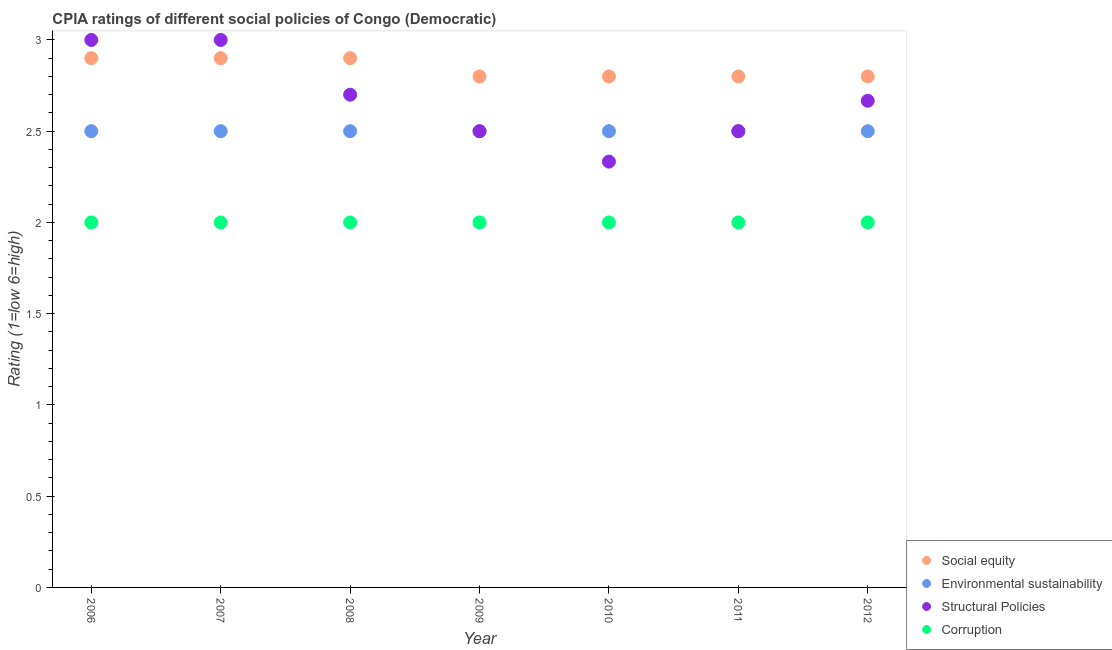Across all years, what is the minimum cpia rating of structural policies?
Your response must be concise. 2.33. What is the total cpia rating of corruption in the graph?
Offer a very short reply. 14. What is the difference between the cpia rating of structural policies in 2010 and that in 2011?
Your response must be concise. -0.17. What is the difference between the cpia rating of structural policies in 2011 and the cpia rating of corruption in 2007?
Keep it short and to the point. 0.5. What is the average cpia rating of structural policies per year?
Offer a very short reply. 2.67. In the year 2006, what is the difference between the cpia rating of structural policies and cpia rating of social equity?
Offer a terse response. 0.1. Is the difference between the cpia rating of corruption in 2006 and 2010 greater than the difference between the cpia rating of environmental sustainability in 2006 and 2010?
Offer a terse response. No. What is the difference between the highest and the second highest cpia rating of environmental sustainability?
Your answer should be compact. 0. What is the difference between the highest and the lowest cpia rating of structural policies?
Your answer should be very brief. 0.67. Is the sum of the cpia rating of social equity in 2008 and 2009 greater than the maximum cpia rating of structural policies across all years?
Your response must be concise. Yes. Does the cpia rating of structural policies monotonically increase over the years?
Ensure brevity in your answer.  No. How many dotlines are there?
Your answer should be very brief. 4. How many years are there in the graph?
Your response must be concise. 7. Are the values on the major ticks of Y-axis written in scientific E-notation?
Provide a succinct answer. No. Does the graph contain any zero values?
Offer a very short reply. No. Does the graph contain grids?
Provide a short and direct response. No. Where does the legend appear in the graph?
Your answer should be compact. Bottom right. How many legend labels are there?
Provide a short and direct response. 4. What is the title of the graph?
Offer a very short reply. CPIA ratings of different social policies of Congo (Democratic). Does "Taxes on goods and services" appear as one of the legend labels in the graph?
Your response must be concise. No. What is the Rating (1=low 6=high) in Environmental sustainability in 2006?
Offer a very short reply. 2.5. What is the Rating (1=low 6=high) in Structural Policies in 2006?
Keep it short and to the point. 3. What is the Rating (1=low 6=high) of Social equity in 2007?
Give a very brief answer. 2.9. What is the Rating (1=low 6=high) in Environmental sustainability in 2007?
Offer a very short reply. 2.5. What is the Rating (1=low 6=high) of Environmental sustainability in 2008?
Provide a succinct answer. 2.5. What is the Rating (1=low 6=high) of Structural Policies in 2008?
Your answer should be very brief. 2.7. What is the Rating (1=low 6=high) in Corruption in 2008?
Your answer should be compact. 2. What is the Rating (1=low 6=high) of Social equity in 2009?
Provide a succinct answer. 2.8. What is the Rating (1=low 6=high) in Environmental sustainability in 2009?
Offer a very short reply. 2.5. What is the Rating (1=low 6=high) in Social equity in 2010?
Provide a short and direct response. 2.8. What is the Rating (1=low 6=high) in Structural Policies in 2010?
Offer a terse response. 2.33. What is the Rating (1=low 6=high) in Corruption in 2010?
Keep it short and to the point. 2. What is the Rating (1=low 6=high) of Social equity in 2011?
Provide a succinct answer. 2.8. What is the Rating (1=low 6=high) of Social equity in 2012?
Your answer should be very brief. 2.8. What is the Rating (1=low 6=high) of Environmental sustainability in 2012?
Provide a short and direct response. 2.5. What is the Rating (1=low 6=high) in Structural Policies in 2012?
Make the answer very short. 2.67. What is the Rating (1=low 6=high) of Corruption in 2012?
Your answer should be compact. 2. Across all years, what is the maximum Rating (1=low 6=high) in Structural Policies?
Provide a short and direct response. 3. Across all years, what is the minimum Rating (1=low 6=high) in Social equity?
Offer a very short reply. 2.8. Across all years, what is the minimum Rating (1=low 6=high) in Structural Policies?
Keep it short and to the point. 2.33. What is the total Rating (1=low 6=high) in Environmental sustainability in the graph?
Keep it short and to the point. 17.5. What is the total Rating (1=low 6=high) of Structural Policies in the graph?
Offer a terse response. 18.7. What is the difference between the Rating (1=low 6=high) in Social equity in 2006 and that in 2007?
Make the answer very short. 0. What is the difference between the Rating (1=low 6=high) of Corruption in 2006 and that in 2007?
Keep it short and to the point. 0. What is the difference between the Rating (1=low 6=high) in Structural Policies in 2006 and that in 2008?
Ensure brevity in your answer.  0.3. What is the difference between the Rating (1=low 6=high) in Structural Policies in 2006 and that in 2009?
Your answer should be compact. 0.5. What is the difference between the Rating (1=low 6=high) of Structural Policies in 2006 and that in 2010?
Give a very brief answer. 0.67. What is the difference between the Rating (1=low 6=high) in Corruption in 2006 and that in 2010?
Offer a very short reply. 0. What is the difference between the Rating (1=low 6=high) of Structural Policies in 2006 and that in 2011?
Keep it short and to the point. 0.5. What is the difference between the Rating (1=low 6=high) in Structural Policies in 2006 and that in 2012?
Provide a succinct answer. 0.33. What is the difference between the Rating (1=low 6=high) in Social equity in 2007 and that in 2008?
Give a very brief answer. 0. What is the difference between the Rating (1=low 6=high) of Structural Policies in 2007 and that in 2008?
Give a very brief answer. 0.3. What is the difference between the Rating (1=low 6=high) of Environmental sustainability in 2007 and that in 2009?
Offer a very short reply. 0. What is the difference between the Rating (1=low 6=high) of Environmental sustainability in 2007 and that in 2010?
Provide a succinct answer. 0. What is the difference between the Rating (1=low 6=high) in Structural Policies in 2007 and that in 2010?
Provide a short and direct response. 0.67. What is the difference between the Rating (1=low 6=high) in Corruption in 2007 and that in 2010?
Your answer should be compact. 0. What is the difference between the Rating (1=low 6=high) of Environmental sustainability in 2007 and that in 2012?
Provide a short and direct response. 0. What is the difference between the Rating (1=low 6=high) of Environmental sustainability in 2008 and that in 2009?
Provide a succinct answer. 0. What is the difference between the Rating (1=low 6=high) of Structural Policies in 2008 and that in 2010?
Make the answer very short. 0.37. What is the difference between the Rating (1=low 6=high) in Environmental sustainability in 2008 and that in 2011?
Your response must be concise. 0. What is the difference between the Rating (1=low 6=high) in Corruption in 2008 and that in 2012?
Make the answer very short. 0. What is the difference between the Rating (1=low 6=high) of Social equity in 2009 and that in 2010?
Ensure brevity in your answer.  0. What is the difference between the Rating (1=low 6=high) of Environmental sustainability in 2009 and that in 2010?
Make the answer very short. 0. What is the difference between the Rating (1=low 6=high) of Structural Policies in 2009 and that in 2010?
Provide a succinct answer. 0.17. What is the difference between the Rating (1=low 6=high) of Corruption in 2009 and that in 2010?
Ensure brevity in your answer.  0. What is the difference between the Rating (1=low 6=high) in Corruption in 2009 and that in 2012?
Offer a terse response. 0. What is the difference between the Rating (1=low 6=high) of Social equity in 2010 and that in 2011?
Keep it short and to the point. 0. What is the difference between the Rating (1=low 6=high) of Structural Policies in 2010 and that in 2011?
Your response must be concise. -0.17. What is the difference between the Rating (1=low 6=high) of Corruption in 2010 and that in 2011?
Keep it short and to the point. 0. What is the difference between the Rating (1=low 6=high) of Social equity in 2010 and that in 2012?
Your answer should be very brief. 0. What is the difference between the Rating (1=low 6=high) in Structural Policies in 2010 and that in 2012?
Provide a short and direct response. -0.33. What is the difference between the Rating (1=low 6=high) in Social equity in 2011 and that in 2012?
Ensure brevity in your answer.  0. What is the difference between the Rating (1=low 6=high) of Structural Policies in 2011 and that in 2012?
Give a very brief answer. -0.17. What is the difference between the Rating (1=low 6=high) in Corruption in 2011 and that in 2012?
Make the answer very short. 0. What is the difference between the Rating (1=low 6=high) in Social equity in 2006 and the Rating (1=low 6=high) in Environmental sustainability in 2007?
Provide a short and direct response. 0.4. What is the difference between the Rating (1=low 6=high) in Social equity in 2006 and the Rating (1=low 6=high) in Corruption in 2007?
Your answer should be very brief. 0.9. What is the difference between the Rating (1=low 6=high) in Environmental sustainability in 2006 and the Rating (1=low 6=high) in Structural Policies in 2007?
Provide a short and direct response. -0.5. What is the difference between the Rating (1=low 6=high) of Environmental sustainability in 2006 and the Rating (1=low 6=high) of Corruption in 2007?
Provide a short and direct response. 0.5. What is the difference between the Rating (1=low 6=high) of Structural Policies in 2006 and the Rating (1=low 6=high) of Corruption in 2008?
Ensure brevity in your answer.  1. What is the difference between the Rating (1=low 6=high) of Social equity in 2006 and the Rating (1=low 6=high) of Structural Policies in 2009?
Keep it short and to the point. 0.4. What is the difference between the Rating (1=low 6=high) in Environmental sustainability in 2006 and the Rating (1=low 6=high) in Corruption in 2009?
Your response must be concise. 0.5. What is the difference between the Rating (1=low 6=high) in Structural Policies in 2006 and the Rating (1=low 6=high) in Corruption in 2009?
Your answer should be compact. 1. What is the difference between the Rating (1=low 6=high) of Social equity in 2006 and the Rating (1=low 6=high) of Environmental sustainability in 2010?
Keep it short and to the point. 0.4. What is the difference between the Rating (1=low 6=high) of Social equity in 2006 and the Rating (1=low 6=high) of Structural Policies in 2010?
Provide a succinct answer. 0.57. What is the difference between the Rating (1=low 6=high) of Social equity in 2006 and the Rating (1=low 6=high) of Corruption in 2010?
Ensure brevity in your answer.  0.9. What is the difference between the Rating (1=low 6=high) of Environmental sustainability in 2006 and the Rating (1=low 6=high) of Structural Policies in 2010?
Provide a short and direct response. 0.17. What is the difference between the Rating (1=low 6=high) of Environmental sustainability in 2006 and the Rating (1=low 6=high) of Corruption in 2010?
Offer a terse response. 0.5. What is the difference between the Rating (1=low 6=high) of Social equity in 2006 and the Rating (1=low 6=high) of Environmental sustainability in 2011?
Offer a terse response. 0.4. What is the difference between the Rating (1=low 6=high) of Social equity in 2006 and the Rating (1=low 6=high) of Structural Policies in 2011?
Give a very brief answer. 0.4. What is the difference between the Rating (1=low 6=high) of Social equity in 2006 and the Rating (1=low 6=high) of Corruption in 2011?
Your response must be concise. 0.9. What is the difference between the Rating (1=low 6=high) of Structural Policies in 2006 and the Rating (1=low 6=high) of Corruption in 2011?
Offer a terse response. 1. What is the difference between the Rating (1=low 6=high) in Social equity in 2006 and the Rating (1=low 6=high) in Structural Policies in 2012?
Provide a short and direct response. 0.23. What is the difference between the Rating (1=low 6=high) in Social equity in 2006 and the Rating (1=low 6=high) in Corruption in 2012?
Offer a terse response. 0.9. What is the difference between the Rating (1=low 6=high) in Social equity in 2007 and the Rating (1=low 6=high) in Structural Policies in 2008?
Provide a short and direct response. 0.2. What is the difference between the Rating (1=low 6=high) in Social equity in 2007 and the Rating (1=low 6=high) in Corruption in 2008?
Your answer should be very brief. 0.9. What is the difference between the Rating (1=low 6=high) of Social equity in 2007 and the Rating (1=low 6=high) of Environmental sustainability in 2009?
Provide a succinct answer. 0.4. What is the difference between the Rating (1=low 6=high) in Social equity in 2007 and the Rating (1=low 6=high) in Corruption in 2009?
Offer a terse response. 0.9. What is the difference between the Rating (1=low 6=high) of Structural Policies in 2007 and the Rating (1=low 6=high) of Corruption in 2009?
Give a very brief answer. 1. What is the difference between the Rating (1=low 6=high) in Social equity in 2007 and the Rating (1=low 6=high) in Environmental sustainability in 2010?
Your answer should be very brief. 0.4. What is the difference between the Rating (1=low 6=high) in Social equity in 2007 and the Rating (1=low 6=high) in Structural Policies in 2010?
Offer a very short reply. 0.57. What is the difference between the Rating (1=low 6=high) in Social equity in 2007 and the Rating (1=low 6=high) in Corruption in 2010?
Your answer should be compact. 0.9. What is the difference between the Rating (1=low 6=high) in Structural Policies in 2007 and the Rating (1=low 6=high) in Corruption in 2010?
Offer a terse response. 1. What is the difference between the Rating (1=low 6=high) in Social equity in 2007 and the Rating (1=low 6=high) in Corruption in 2011?
Offer a very short reply. 0.9. What is the difference between the Rating (1=low 6=high) of Environmental sustainability in 2007 and the Rating (1=low 6=high) of Structural Policies in 2011?
Offer a terse response. 0. What is the difference between the Rating (1=low 6=high) in Environmental sustainability in 2007 and the Rating (1=low 6=high) in Corruption in 2011?
Your answer should be compact. 0.5. What is the difference between the Rating (1=low 6=high) in Structural Policies in 2007 and the Rating (1=low 6=high) in Corruption in 2011?
Keep it short and to the point. 1. What is the difference between the Rating (1=low 6=high) of Social equity in 2007 and the Rating (1=low 6=high) of Structural Policies in 2012?
Keep it short and to the point. 0.23. What is the difference between the Rating (1=low 6=high) of Environmental sustainability in 2007 and the Rating (1=low 6=high) of Structural Policies in 2012?
Offer a terse response. -0.17. What is the difference between the Rating (1=low 6=high) of Social equity in 2008 and the Rating (1=low 6=high) of Structural Policies in 2009?
Offer a terse response. 0.4. What is the difference between the Rating (1=low 6=high) of Social equity in 2008 and the Rating (1=low 6=high) of Corruption in 2009?
Make the answer very short. 0.9. What is the difference between the Rating (1=low 6=high) of Environmental sustainability in 2008 and the Rating (1=low 6=high) of Structural Policies in 2009?
Keep it short and to the point. 0. What is the difference between the Rating (1=low 6=high) of Environmental sustainability in 2008 and the Rating (1=low 6=high) of Corruption in 2009?
Offer a terse response. 0.5. What is the difference between the Rating (1=low 6=high) in Social equity in 2008 and the Rating (1=low 6=high) in Structural Policies in 2010?
Your response must be concise. 0.57. What is the difference between the Rating (1=low 6=high) in Social equity in 2008 and the Rating (1=low 6=high) in Corruption in 2010?
Your response must be concise. 0.9. What is the difference between the Rating (1=low 6=high) in Environmental sustainability in 2008 and the Rating (1=low 6=high) in Structural Policies in 2010?
Offer a terse response. 0.17. What is the difference between the Rating (1=low 6=high) of Environmental sustainability in 2008 and the Rating (1=low 6=high) of Corruption in 2010?
Offer a terse response. 0.5. What is the difference between the Rating (1=low 6=high) of Social equity in 2008 and the Rating (1=low 6=high) of Environmental sustainability in 2011?
Offer a very short reply. 0.4. What is the difference between the Rating (1=low 6=high) in Environmental sustainability in 2008 and the Rating (1=low 6=high) in Structural Policies in 2011?
Make the answer very short. 0. What is the difference between the Rating (1=low 6=high) of Structural Policies in 2008 and the Rating (1=low 6=high) of Corruption in 2011?
Provide a short and direct response. 0.7. What is the difference between the Rating (1=low 6=high) in Social equity in 2008 and the Rating (1=low 6=high) in Environmental sustainability in 2012?
Offer a terse response. 0.4. What is the difference between the Rating (1=low 6=high) of Social equity in 2008 and the Rating (1=low 6=high) of Structural Policies in 2012?
Provide a succinct answer. 0.23. What is the difference between the Rating (1=low 6=high) in Structural Policies in 2008 and the Rating (1=low 6=high) in Corruption in 2012?
Offer a very short reply. 0.7. What is the difference between the Rating (1=low 6=high) of Social equity in 2009 and the Rating (1=low 6=high) of Environmental sustainability in 2010?
Make the answer very short. 0.3. What is the difference between the Rating (1=low 6=high) in Social equity in 2009 and the Rating (1=low 6=high) in Structural Policies in 2010?
Your answer should be very brief. 0.47. What is the difference between the Rating (1=low 6=high) of Social equity in 2009 and the Rating (1=low 6=high) of Environmental sustainability in 2011?
Offer a terse response. 0.3. What is the difference between the Rating (1=low 6=high) in Social equity in 2009 and the Rating (1=low 6=high) in Structural Policies in 2011?
Offer a terse response. 0.3. What is the difference between the Rating (1=low 6=high) in Environmental sustainability in 2009 and the Rating (1=low 6=high) in Structural Policies in 2011?
Offer a very short reply. 0. What is the difference between the Rating (1=low 6=high) of Environmental sustainability in 2009 and the Rating (1=low 6=high) of Corruption in 2011?
Give a very brief answer. 0.5. What is the difference between the Rating (1=low 6=high) of Structural Policies in 2009 and the Rating (1=low 6=high) of Corruption in 2011?
Provide a short and direct response. 0.5. What is the difference between the Rating (1=low 6=high) in Social equity in 2009 and the Rating (1=low 6=high) in Structural Policies in 2012?
Offer a very short reply. 0.13. What is the difference between the Rating (1=low 6=high) in Social equity in 2009 and the Rating (1=low 6=high) in Corruption in 2012?
Ensure brevity in your answer.  0.8. What is the difference between the Rating (1=low 6=high) in Environmental sustainability in 2009 and the Rating (1=low 6=high) in Structural Policies in 2012?
Ensure brevity in your answer.  -0.17. What is the difference between the Rating (1=low 6=high) of Environmental sustainability in 2009 and the Rating (1=low 6=high) of Corruption in 2012?
Give a very brief answer. 0.5. What is the difference between the Rating (1=low 6=high) of Social equity in 2010 and the Rating (1=low 6=high) of Environmental sustainability in 2011?
Your response must be concise. 0.3. What is the difference between the Rating (1=low 6=high) of Social equity in 2010 and the Rating (1=low 6=high) of Corruption in 2011?
Ensure brevity in your answer.  0.8. What is the difference between the Rating (1=low 6=high) in Environmental sustainability in 2010 and the Rating (1=low 6=high) in Structural Policies in 2011?
Make the answer very short. 0. What is the difference between the Rating (1=low 6=high) in Structural Policies in 2010 and the Rating (1=low 6=high) in Corruption in 2011?
Keep it short and to the point. 0.33. What is the difference between the Rating (1=low 6=high) of Social equity in 2010 and the Rating (1=low 6=high) of Environmental sustainability in 2012?
Your response must be concise. 0.3. What is the difference between the Rating (1=low 6=high) in Social equity in 2010 and the Rating (1=low 6=high) in Structural Policies in 2012?
Your answer should be very brief. 0.13. What is the difference between the Rating (1=low 6=high) of Social equity in 2010 and the Rating (1=low 6=high) of Corruption in 2012?
Keep it short and to the point. 0.8. What is the difference between the Rating (1=low 6=high) in Social equity in 2011 and the Rating (1=low 6=high) in Structural Policies in 2012?
Ensure brevity in your answer.  0.13. What is the difference between the Rating (1=low 6=high) in Structural Policies in 2011 and the Rating (1=low 6=high) in Corruption in 2012?
Provide a succinct answer. 0.5. What is the average Rating (1=low 6=high) in Social equity per year?
Give a very brief answer. 2.84. What is the average Rating (1=low 6=high) in Environmental sustainability per year?
Provide a short and direct response. 2.5. What is the average Rating (1=low 6=high) in Structural Policies per year?
Offer a very short reply. 2.67. In the year 2006, what is the difference between the Rating (1=low 6=high) in Social equity and Rating (1=low 6=high) in Environmental sustainability?
Your response must be concise. 0.4. In the year 2006, what is the difference between the Rating (1=low 6=high) of Social equity and Rating (1=low 6=high) of Corruption?
Ensure brevity in your answer.  0.9. In the year 2006, what is the difference between the Rating (1=low 6=high) of Environmental sustainability and Rating (1=low 6=high) of Structural Policies?
Provide a short and direct response. -0.5. In the year 2006, what is the difference between the Rating (1=low 6=high) of Environmental sustainability and Rating (1=low 6=high) of Corruption?
Make the answer very short. 0.5. In the year 2006, what is the difference between the Rating (1=low 6=high) of Structural Policies and Rating (1=low 6=high) of Corruption?
Make the answer very short. 1. In the year 2007, what is the difference between the Rating (1=low 6=high) in Social equity and Rating (1=low 6=high) in Structural Policies?
Ensure brevity in your answer.  -0.1. In the year 2007, what is the difference between the Rating (1=low 6=high) of Environmental sustainability and Rating (1=low 6=high) of Structural Policies?
Keep it short and to the point. -0.5. In the year 2007, what is the difference between the Rating (1=low 6=high) in Structural Policies and Rating (1=low 6=high) in Corruption?
Provide a succinct answer. 1. In the year 2008, what is the difference between the Rating (1=low 6=high) of Social equity and Rating (1=low 6=high) of Environmental sustainability?
Your answer should be very brief. 0.4. In the year 2008, what is the difference between the Rating (1=low 6=high) of Social equity and Rating (1=low 6=high) of Structural Policies?
Offer a very short reply. 0.2. In the year 2008, what is the difference between the Rating (1=low 6=high) in Social equity and Rating (1=low 6=high) in Corruption?
Give a very brief answer. 0.9. In the year 2008, what is the difference between the Rating (1=low 6=high) of Environmental sustainability and Rating (1=low 6=high) of Corruption?
Ensure brevity in your answer.  0.5. In the year 2008, what is the difference between the Rating (1=low 6=high) of Structural Policies and Rating (1=low 6=high) of Corruption?
Your answer should be very brief. 0.7. In the year 2009, what is the difference between the Rating (1=low 6=high) of Social equity and Rating (1=low 6=high) of Environmental sustainability?
Your answer should be very brief. 0.3. In the year 2009, what is the difference between the Rating (1=low 6=high) of Social equity and Rating (1=low 6=high) of Structural Policies?
Give a very brief answer. 0.3. In the year 2009, what is the difference between the Rating (1=low 6=high) in Social equity and Rating (1=low 6=high) in Corruption?
Your response must be concise. 0.8. In the year 2009, what is the difference between the Rating (1=low 6=high) of Environmental sustainability and Rating (1=low 6=high) of Structural Policies?
Offer a very short reply. 0. In the year 2010, what is the difference between the Rating (1=low 6=high) in Social equity and Rating (1=low 6=high) in Environmental sustainability?
Ensure brevity in your answer.  0.3. In the year 2010, what is the difference between the Rating (1=low 6=high) in Social equity and Rating (1=low 6=high) in Structural Policies?
Keep it short and to the point. 0.47. In the year 2010, what is the difference between the Rating (1=low 6=high) of Social equity and Rating (1=low 6=high) of Corruption?
Provide a short and direct response. 0.8. In the year 2010, what is the difference between the Rating (1=low 6=high) of Environmental sustainability and Rating (1=low 6=high) of Structural Policies?
Offer a terse response. 0.17. In the year 2010, what is the difference between the Rating (1=low 6=high) in Environmental sustainability and Rating (1=low 6=high) in Corruption?
Provide a succinct answer. 0.5. In the year 2011, what is the difference between the Rating (1=low 6=high) in Social equity and Rating (1=low 6=high) in Structural Policies?
Ensure brevity in your answer.  0.3. In the year 2011, what is the difference between the Rating (1=low 6=high) of Social equity and Rating (1=low 6=high) of Corruption?
Ensure brevity in your answer.  0.8. In the year 2011, what is the difference between the Rating (1=low 6=high) of Environmental sustainability and Rating (1=low 6=high) of Structural Policies?
Provide a short and direct response. 0. In the year 2011, what is the difference between the Rating (1=low 6=high) of Structural Policies and Rating (1=low 6=high) of Corruption?
Offer a very short reply. 0.5. In the year 2012, what is the difference between the Rating (1=low 6=high) of Social equity and Rating (1=low 6=high) of Structural Policies?
Provide a short and direct response. 0.13. In the year 2012, what is the difference between the Rating (1=low 6=high) of Social equity and Rating (1=low 6=high) of Corruption?
Give a very brief answer. 0.8. In the year 2012, what is the difference between the Rating (1=low 6=high) of Structural Policies and Rating (1=low 6=high) of Corruption?
Offer a terse response. 0.67. What is the ratio of the Rating (1=low 6=high) of Social equity in 2006 to that in 2007?
Offer a very short reply. 1. What is the ratio of the Rating (1=low 6=high) of Environmental sustainability in 2006 to that in 2007?
Provide a succinct answer. 1. What is the ratio of the Rating (1=low 6=high) of Structural Policies in 2006 to that in 2007?
Give a very brief answer. 1. What is the ratio of the Rating (1=low 6=high) of Corruption in 2006 to that in 2007?
Provide a short and direct response. 1. What is the ratio of the Rating (1=low 6=high) of Social equity in 2006 to that in 2008?
Make the answer very short. 1. What is the ratio of the Rating (1=low 6=high) in Environmental sustainability in 2006 to that in 2008?
Your answer should be very brief. 1. What is the ratio of the Rating (1=low 6=high) of Social equity in 2006 to that in 2009?
Provide a succinct answer. 1.04. What is the ratio of the Rating (1=low 6=high) of Social equity in 2006 to that in 2010?
Offer a very short reply. 1.04. What is the ratio of the Rating (1=low 6=high) of Corruption in 2006 to that in 2010?
Offer a terse response. 1. What is the ratio of the Rating (1=low 6=high) of Social equity in 2006 to that in 2011?
Offer a very short reply. 1.04. What is the ratio of the Rating (1=low 6=high) in Environmental sustainability in 2006 to that in 2011?
Your answer should be very brief. 1. What is the ratio of the Rating (1=low 6=high) in Structural Policies in 2006 to that in 2011?
Your answer should be very brief. 1.2. What is the ratio of the Rating (1=low 6=high) in Corruption in 2006 to that in 2011?
Offer a terse response. 1. What is the ratio of the Rating (1=low 6=high) in Social equity in 2006 to that in 2012?
Your answer should be compact. 1.04. What is the ratio of the Rating (1=low 6=high) of Environmental sustainability in 2006 to that in 2012?
Your answer should be very brief. 1. What is the ratio of the Rating (1=low 6=high) in Corruption in 2006 to that in 2012?
Keep it short and to the point. 1. What is the ratio of the Rating (1=low 6=high) in Environmental sustainability in 2007 to that in 2008?
Offer a terse response. 1. What is the ratio of the Rating (1=low 6=high) of Social equity in 2007 to that in 2009?
Keep it short and to the point. 1.04. What is the ratio of the Rating (1=low 6=high) in Corruption in 2007 to that in 2009?
Ensure brevity in your answer.  1. What is the ratio of the Rating (1=low 6=high) of Social equity in 2007 to that in 2010?
Offer a terse response. 1.04. What is the ratio of the Rating (1=low 6=high) in Corruption in 2007 to that in 2010?
Your answer should be compact. 1. What is the ratio of the Rating (1=low 6=high) of Social equity in 2007 to that in 2011?
Offer a terse response. 1.04. What is the ratio of the Rating (1=low 6=high) in Environmental sustainability in 2007 to that in 2011?
Offer a very short reply. 1. What is the ratio of the Rating (1=low 6=high) of Corruption in 2007 to that in 2011?
Ensure brevity in your answer.  1. What is the ratio of the Rating (1=low 6=high) in Social equity in 2007 to that in 2012?
Provide a succinct answer. 1.04. What is the ratio of the Rating (1=low 6=high) in Environmental sustainability in 2007 to that in 2012?
Ensure brevity in your answer.  1. What is the ratio of the Rating (1=low 6=high) in Structural Policies in 2007 to that in 2012?
Ensure brevity in your answer.  1.12. What is the ratio of the Rating (1=low 6=high) of Corruption in 2007 to that in 2012?
Provide a short and direct response. 1. What is the ratio of the Rating (1=low 6=high) of Social equity in 2008 to that in 2009?
Offer a terse response. 1.04. What is the ratio of the Rating (1=low 6=high) in Corruption in 2008 to that in 2009?
Ensure brevity in your answer.  1. What is the ratio of the Rating (1=low 6=high) of Social equity in 2008 to that in 2010?
Your answer should be compact. 1.04. What is the ratio of the Rating (1=low 6=high) of Environmental sustainability in 2008 to that in 2010?
Your answer should be very brief. 1. What is the ratio of the Rating (1=low 6=high) in Structural Policies in 2008 to that in 2010?
Ensure brevity in your answer.  1.16. What is the ratio of the Rating (1=low 6=high) of Corruption in 2008 to that in 2010?
Offer a terse response. 1. What is the ratio of the Rating (1=low 6=high) in Social equity in 2008 to that in 2011?
Keep it short and to the point. 1.04. What is the ratio of the Rating (1=low 6=high) in Environmental sustainability in 2008 to that in 2011?
Give a very brief answer. 1. What is the ratio of the Rating (1=low 6=high) of Structural Policies in 2008 to that in 2011?
Offer a terse response. 1.08. What is the ratio of the Rating (1=low 6=high) in Social equity in 2008 to that in 2012?
Offer a terse response. 1.04. What is the ratio of the Rating (1=low 6=high) of Structural Policies in 2008 to that in 2012?
Provide a short and direct response. 1.01. What is the ratio of the Rating (1=low 6=high) of Corruption in 2008 to that in 2012?
Ensure brevity in your answer.  1. What is the ratio of the Rating (1=low 6=high) of Social equity in 2009 to that in 2010?
Your answer should be compact. 1. What is the ratio of the Rating (1=low 6=high) of Structural Policies in 2009 to that in 2010?
Provide a succinct answer. 1.07. What is the ratio of the Rating (1=low 6=high) in Social equity in 2009 to that in 2011?
Ensure brevity in your answer.  1. What is the ratio of the Rating (1=low 6=high) in Environmental sustainability in 2009 to that in 2011?
Your response must be concise. 1. What is the ratio of the Rating (1=low 6=high) in Corruption in 2009 to that in 2011?
Make the answer very short. 1. What is the ratio of the Rating (1=low 6=high) in Social equity in 2009 to that in 2012?
Ensure brevity in your answer.  1. What is the ratio of the Rating (1=low 6=high) in Environmental sustainability in 2009 to that in 2012?
Give a very brief answer. 1. What is the ratio of the Rating (1=low 6=high) in Environmental sustainability in 2010 to that in 2011?
Your answer should be very brief. 1. What is the ratio of the Rating (1=low 6=high) in Structural Policies in 2010 to that in 2011?
Your answer should be very brief. 0.93. What is the ratio of the Rating (1=low 6=high) of Corruption in 2010 to that in 2011?
Ensure brevity in your answer.  1. What is the ratio of the Rating (1=low 6=high) of Social equity in 2010 to that in 2012?
Your answer should be very brief. 1. What is the ratio of the Rating (1=low 6=high) in Environmental sustainability in 2010 to that in 2012?
Your answer should be very brief. 1. What is the ratio of the Rating (1=low 6=high) of Corruption in 2010 to that in 2012?
Your response must be concise. 1. What is the ratio of the Rating (1=low 6=high) of Environmental sustainability in 2011 to that in 2012?
Your response must be concise. 1. What is the ratio of the Rating (1=low 6=high) of Structural Policies in 2011 to that in 2012?
Offer a terse response. 0.94. What is the ratio of the Rating (1=low 6=high) in Corruption in 2011 to that in 2012?
Make the answer very short. 1. What is the difference between the highest and the second highest Rating (1=low 6=high) in Social equity?
Your response must be concise. 0. What is the difference between the highest and the second highest Rating (1=low 6=high) in Environmental sustainability?
Give a very brief answer. 0. What is the difference between the highest and the lowest Rating (1=low 6=high) in Social equity?
Provide a short and direct response. 0.1. What is the difference between the highest and the lowest Rating (1=low 6=high) in Structural Policies?
Your answer should be very brief. 0.67. What is the difference between the highest and the lowest Rating (1=low 6=high) in Corruption?
Provide a succinct answer. 0. 